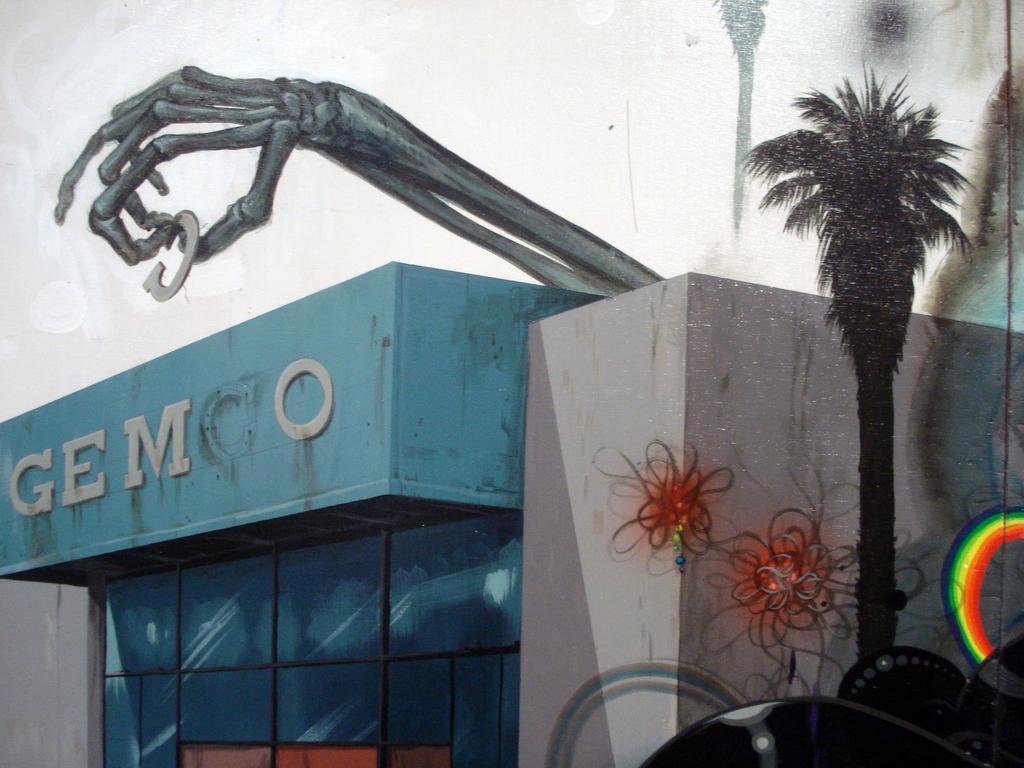Please provide a concise description of this image. In this picture I can see a drawing, where there is a building, there is a skeleton of a hand holding an alphabet, there is a tree, rainbow, there are scribblings on the wall and there are some other objects. 